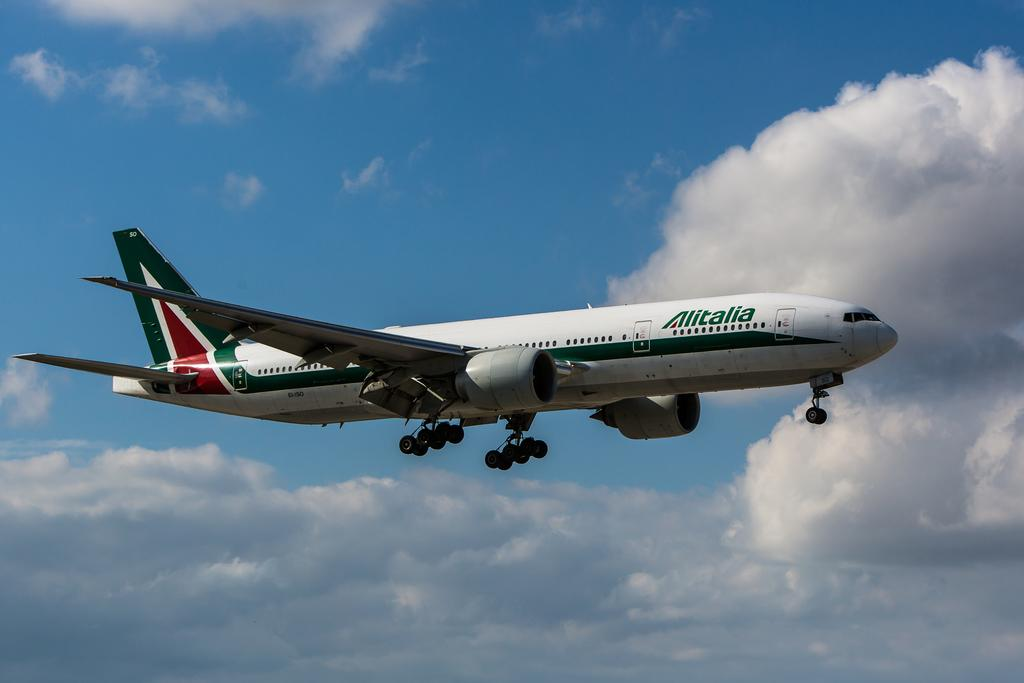What is the main subject of the image? The main subject of the image is an aircraft. What colors are used to paint the aircraft? The aircraft is in white and green color. What can be seen in the background of the image? The sky is visible in the background of the image. What colors are used to depict the sky? The sky is in white and blue color. Can you see any cattle grazing in the image? No, there are no cattle present in the image. Is there a spade being used by the aircraft in the image? No, there is no spade or any tool being used by the aircraft in the image. 